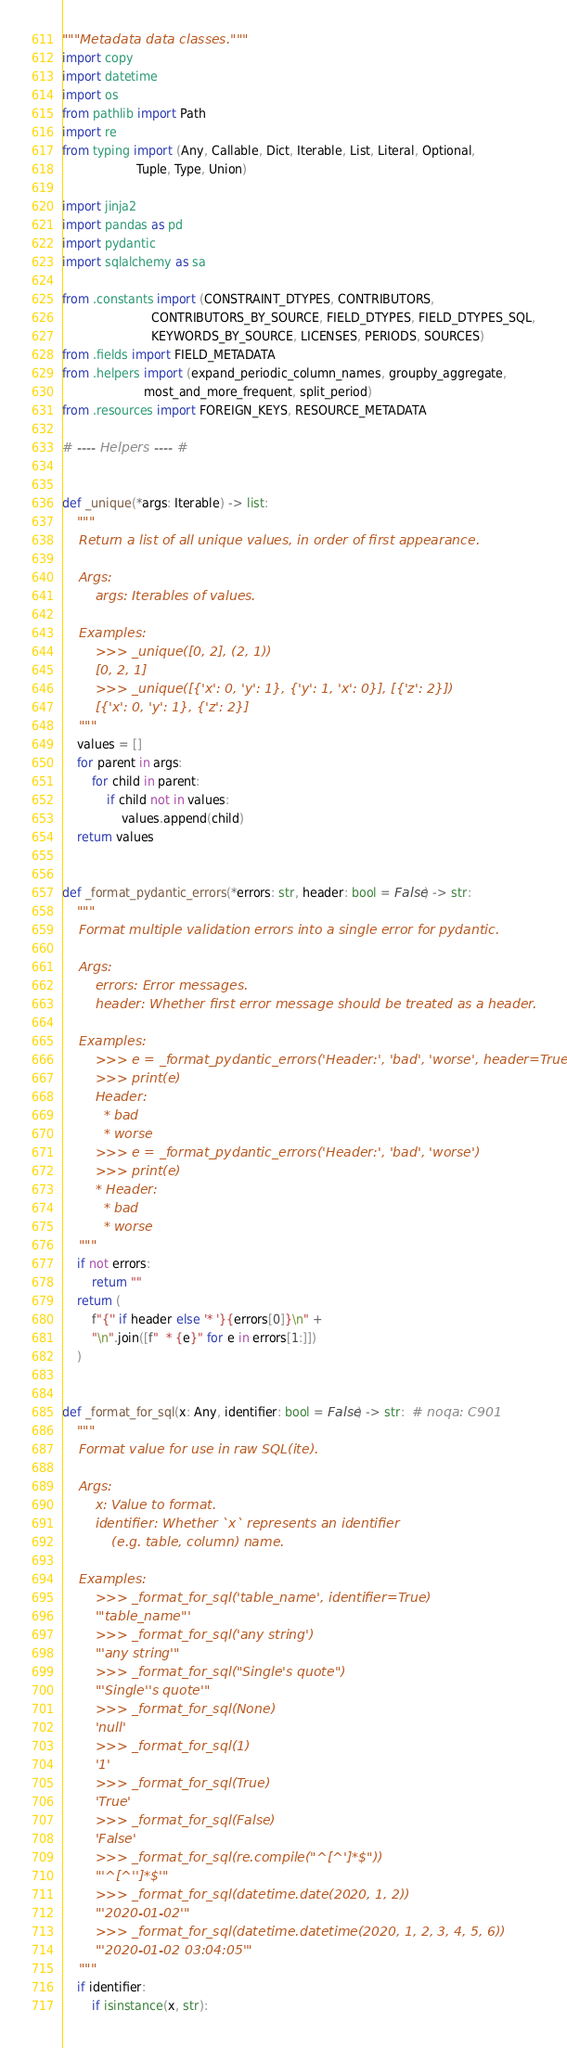Convert code to text. <code><loc_0><loc_0><loc_500><loc_500><_Python_>"""Metadata data classes."""
import copy
import datetime
import os
from pathlib import Path
import re
from typing import (Any, Callable, Dict, Iterable, List, Literal, Optional,
                    Tuple, Type, Union)

import jinja2
import pandas as pd
import pydantic
import sqlalchemy as sa

from .constants import (CONSTRAINT_DTYPES, CONTRIBUTORS,
                        CONTRIBUTORS_BY_SOURCE, FIELD_DTYPES, FIELD_DTYPES_SQL,
                        KEYWORDS_BY_SOURCE, LICENSES, PERIODS, SOURCES)
from .fields import FIELD_METADATA
from .helpers import (expand_periodic_column_names, groupby_aggregate,
                      most_and_more_frequent, split_period)
from .resources import FOREIGN_KEYS, RESOURCE_METADATA

# ---- Helpers ---- #


def _unique(*args: Iterable) -> list:
    """
    Return a list of all unique values, in order of first appearance.

    Args:
        args: Iterables of values.

    Examples:
        >>> _unique([0, 2], (2, 1))
        [0, 2, 1]
        >>> _unique([{'x': 0, 'y': 1}, {'y': 1, 'x': 0}], [{'z': 2}])
        [{'x': 0, 'y': 1}, {'z': 2}]
    """
    values = []
    for parent in args:
        for child in parent:
            if child not in values:
                values.append(child)
    return values


def _format_pydantic_errors(*errors: str, header: bool = False) -> str:
    """
    Format multiple validation errors into a single error for pydantic.

    Args:
        errors: Error messages.
        header: Whether first error message should be treated as a header.

    Examples:
        >>> e = _format_pydantic_errors('Header:', 'bad', 'worse', header=True)
        >>> print(e)
        Header:
          * bad
          * worse
        >>> e = _format_pydantic_errors('Header:', 'bad', 'worse')
        >>> print(e)
        * Header:
          * bad
          * worse
    """
    if not errors:
        return ""
    return (
        f"{'' if header else '* '}{errors[0]}\n" +
        "\n".join([f"  * {e}" for e in errors[1:]])
    )


def _format_for_sql(x: Any, identifier: bool = False) -> str:  # noqa: C901
    """
    Format value for use in raw SQL(ite).

    Args:
        x: Value to format.
        identifier: Whether `x` represents an identifier
            (e.g. table, column) name.

    Examples:
        >>> _format_for_sql('table_name', identifier=True)
        '"table_name"'
        >>> _format_for_sql('any string')
        "'any string'"
        >>> _format_for_sql("Single's quote")
        "'Single''s quote'"
        >>> _format_for_sql(None)
        'null'
        >>> _format_for_sql(1)
        '1'
        >>> _format_for_sql(True)
        'True'
        >>> _format_for_sql(False)
        'False'
        >>> _format_for_sql(re.compile("^[^']*$"))
        "'^[^'']*$'"
        >>> _format_for_sql(datetime.date(2020, 1, 2))
        "'2020-01-02'"
        >>> _format_for_sql(datetime.datetime(2020, 1, 2, 3, 4, 5, 6))
        "'2020-01-02 03:04:05'"
    """
    if identifier:
        if isinstance(x, str):</code> 